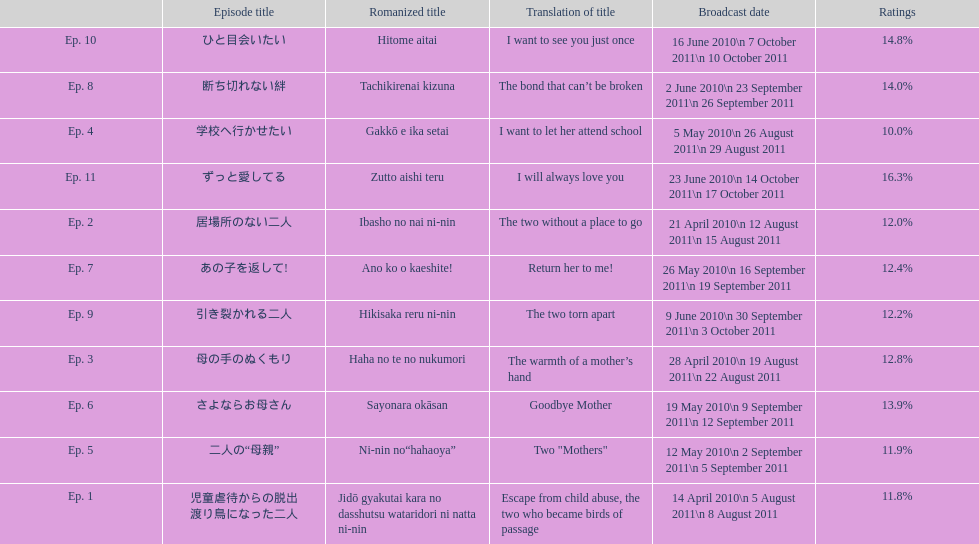What was the most acclaimed episode of this show? ずっと愛してる. 